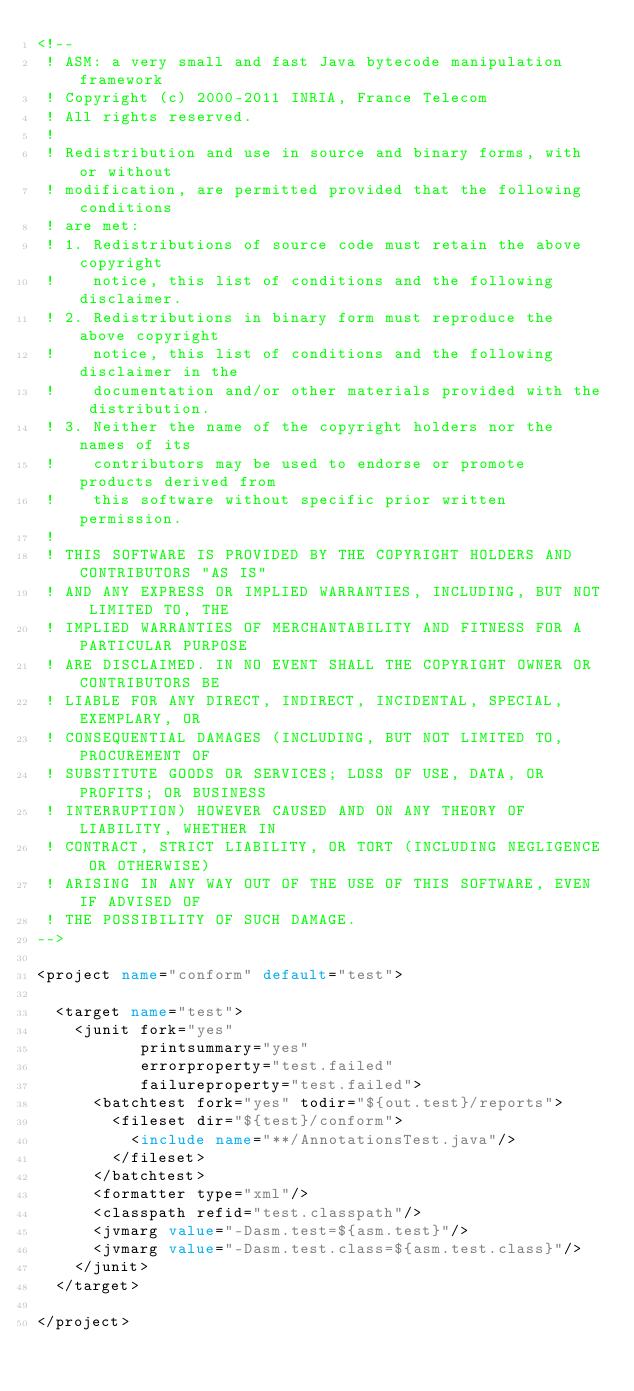<code> <loc_0><loc_0><loc_500><loc_500><_XML_><!--
 ! ASM: a very small and fast Java bytecode manipulation framework
 ! Copyright (c) 2000-2011 INRIA, France Telecom
 ! All rights reserved.
 !
 ! Redistribution and use in source and binary forms, with or without
 ! modification, are permitted provided that the following conditions
 ! are met:
 ! 1. Redistributions of source code must retain the above copyright
 !    notice, this list of conditions and the following disclaimer.
 ! 2. Redistributions in binary form must reproduce the above copyright
 !    notice, this list of conditions and the following disclaimer in the
 !    documentation and/or other materials provided with the distribution.
 ! 3. Neither the name of the copyright holders nor the names of its
 !    contributors may be used to endorse or promote products derived from
 !    this software without specific prior written permission.
 !
 ! THIS SOFTWARE IS PROVIDED BY THE COPYRIGHT HOLDERS AND CONTRIBUTORS "AS IS"
 ! AND ANY EXPRESS OR IMPLIED WARRANTIES, INCLUDING, BUT NOT LIMITED TO, THE
 ! IMPLIED WARRANTIES OF MERCHANTABILITY AND FITNESS FOR A PARTICULAR PURPOSE
 ! ARE DISCLAIMED. IN NO EVENT SHALL THE COPYRIGHT OWNER OR CONTRIBUTORS BE
 ! LIABLE FOR ANY DIRECT, INDIRECT, INCIDENTAL, SPECIAL, EXEMPLARY, OR
 ! CONSEQUENTIAL DAMAGES (INCLUDING, BUT NOT LIMITED TO, PROCUREMENT OF
 ! SUBSTITUTE GOODS OR SERVICES; LOSS OF USE, DATA, OR PROFITS; OR BUSINESS
 ! INTERRUPTION) HOWEVER CAUSED AND ON ANY THEORY OF LIABILITY, WHETHER IN
 ! CONTRACT, STRICT LIABILITY, OR TORT (INCLUDING NEGLIGENCE OR OTHERWISE)
 ! ARISING IN ANY WAY OUT OF THE USE OF THIS SOFTWARE, EVEN IF ADVISED OF
 ! THE POSSIBILITY OF SUCH DAMAGE.
-->

<project name="conform" default="test">

  <target name="test">
    <junit fork="yes" 
           printsummary="yes"
           errorproperty="test.failed"
           failureproperty="test.failed">
      <batchtest fork="yes" todir="${out.test}/reports">
        <fileset dir="${test}/conform">
          <include name="**/AnnotationsTest.java"/>
        </fileset>
      </batchtest>
      <formatter type="xml"/>
      <classpath refid="test.classpath"/>
      <jvmarg value="-Dasm.test=${asm.test}"/>
      <jvmarg value="-Dasm.test.class=${asm.test.class}"/>
    </junit>
  </target>

</project>
</code> 